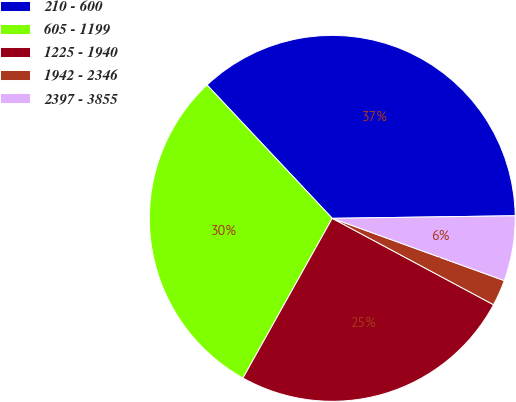<chart> <loc_0><loc_0><loc_500><loc_500><pie_chart><fcel>210 - 600<fcel>605 - 1199<fcel>1225 - 1940<fcel>1942 - 2346<fcel>2397 - 3855<nl><fcel>36.78%<fcel>29.89%<fcel>25.29%<fcel>2.3%<fcel>5.75%<nl></chart> 